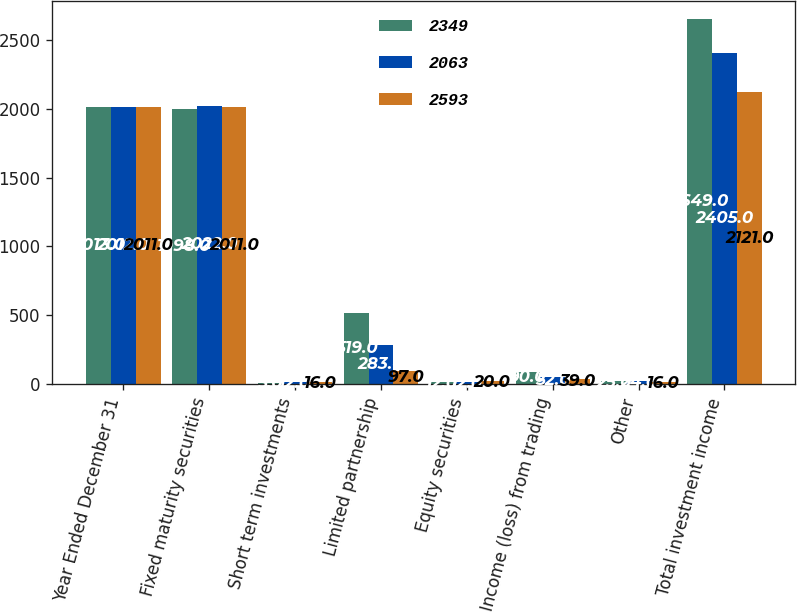Convert chart. <chart><loc_0><loc_0><loc_500><loc_500><stacked_bar_chart><ecel><fcel>Year Ended December 31<fcel>Fixed maturity securities<fcel>Short term investments<fcel>Limited partnership<fcel>Equity securities<fcel>Income (loss) from trading<fcel>Other<fcel>Total investment income<nl><fcel>2349<fcel>2013<fcel>1998<fcel>5<fcel>519<fcel>12<fcel>90<fcel>25<fcel>2649<nl><fcel>2063<fcel>2012<fcel>2022<fcel>12<fcel>283<fcel>12<fcel>52<fcel>24<fcel>2405<nl><fcel>2593<fcel>2011<fcel>2011<fcel>16<fcel>97<fcel>20<fcel>39<fcel>16<fcel>2121<nl></chart> 